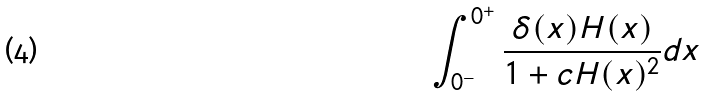<formula> <loc_0><loc_0><loc_500><loc_500>\int _ { 0 ^ { - } } ^ { 0 ^ { + } } \frac { \delta ( x ) H ( x ) } { 1 + c H ( x ) ^ { 2 } } d x</formula> 